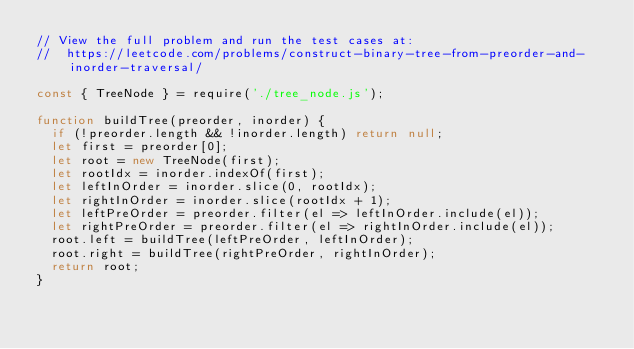Convert code to text. <code><loc_0><loc_0><loc_500><loc_500><_JavaScript_>// View the full problem and run the test cases at:
//  https://leetcode.com/problems/construct-binary-tree-from-preorder-and-inorder-traversal/

const { TreeNode } = require('./tree_node.js');

function buildTree(preorder, inorder) {
  if (!preorder.length && !inorder.length) return null;
  let first = preorder[0];
  let root = new TreeNode(first);
  let rootIdx = inorder.indexOf(first);
  let leftInOrder = inorder.slice(0, rootIdx);
  let rightInOrder = inorder.slice(rootIdx + 1);
  let leftPreOrder = preorder.filter(el => leftInOrder.include(el));
  let rightPreOrder = preorder.filter(el => rightInOrder.include(el));
  root.left = buildTree(leftPreOrder, leftInOrder);
  root.right = buildTree(rightPreOrder, rightInOrder);
  return root;
}
</code> 